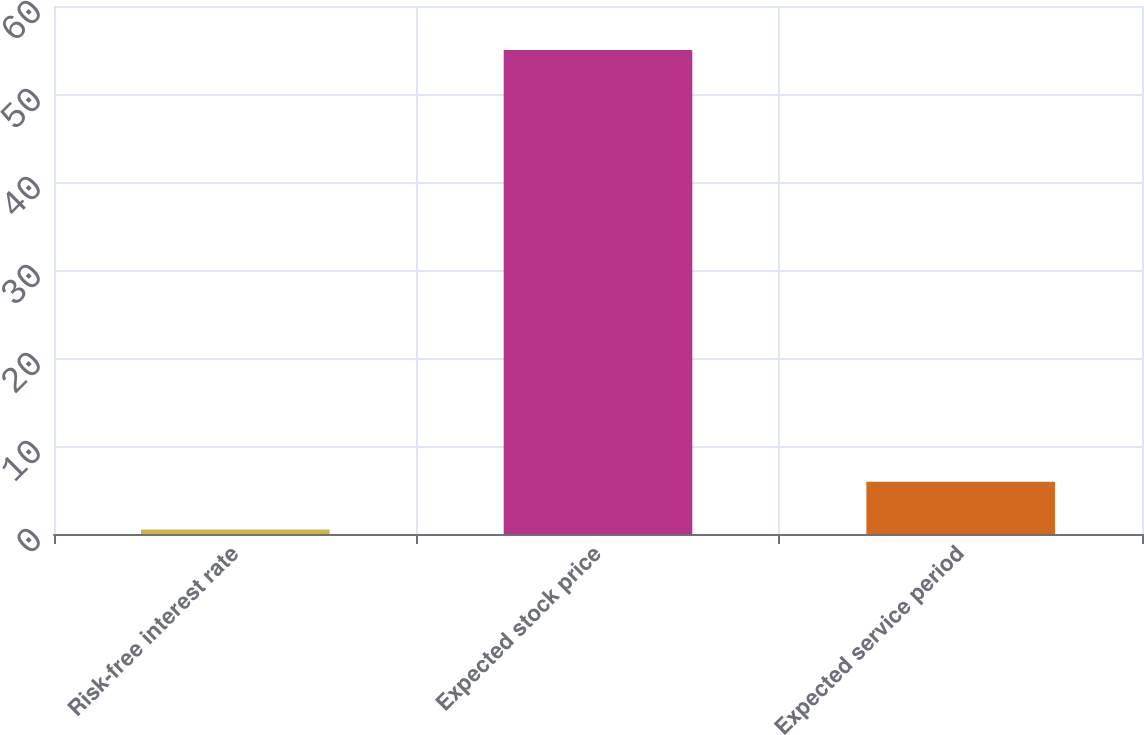Convert chart to OTSL. <chart><loc_0><loc_0><loc_500><loc_500><bar_chart><fcel>Risk-free interest rate<fcel>Expected stock price<fcel>Expected service period<nl><fcel>0.5<fcel>55<fcel>5.95<nl></chart> 